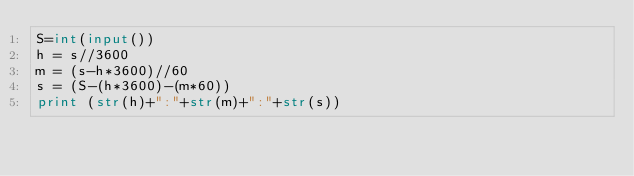<code> <loc_0><loc_0><loc_500><loc_500><_Python_>S=int(input())
h = s//3600
m = (s-h*3600)//60
s = (S-(h*3600)-(m*60))
print (str(h)+":"+str(m)+":"+str(s))
</code> 